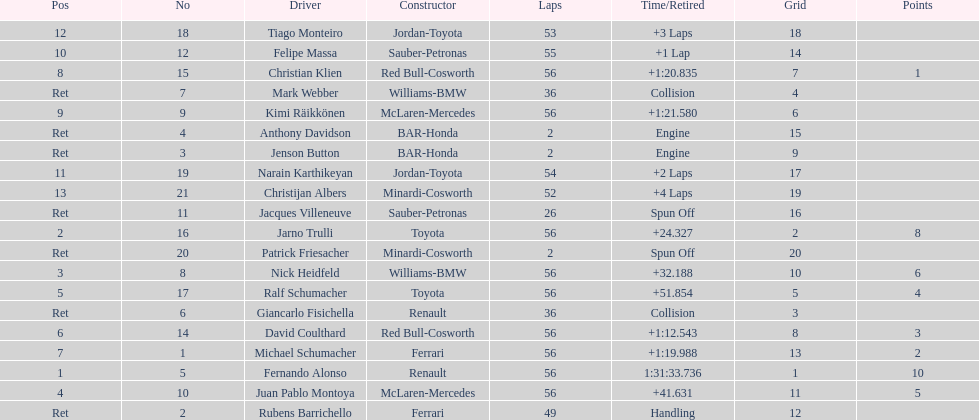Who was the last driver to actually finish the race? Christijan Albers. 